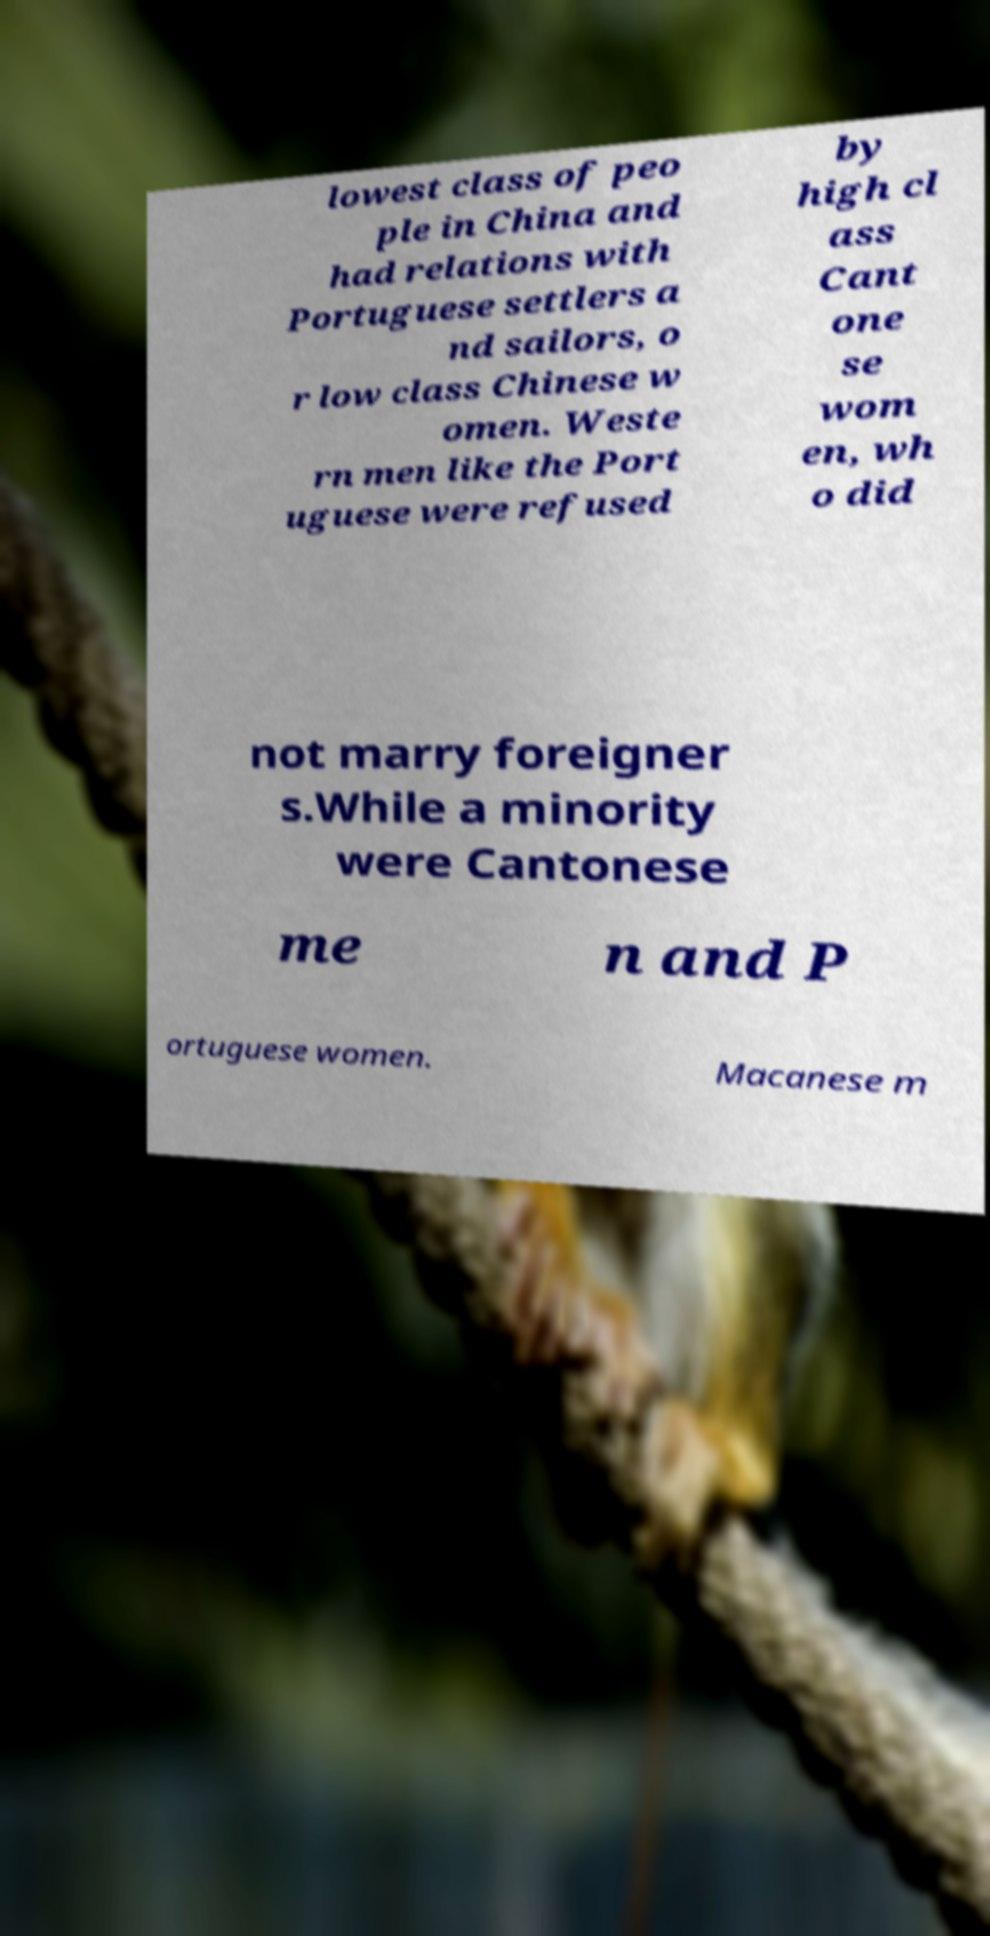There's text embedded in this image that I need extracted. Can you transcribe it verbatim? lowest class of peo ple in China and had relations with Portuguese settlers a nd sailors, o r low class Chinese w omen. Weste rn men like the Port uguese were refused by high cl ass Cant one se wom en, wh o did not marry foreigner s.While a minority were Cantonese me n and P ortuguese women. Macanese m 